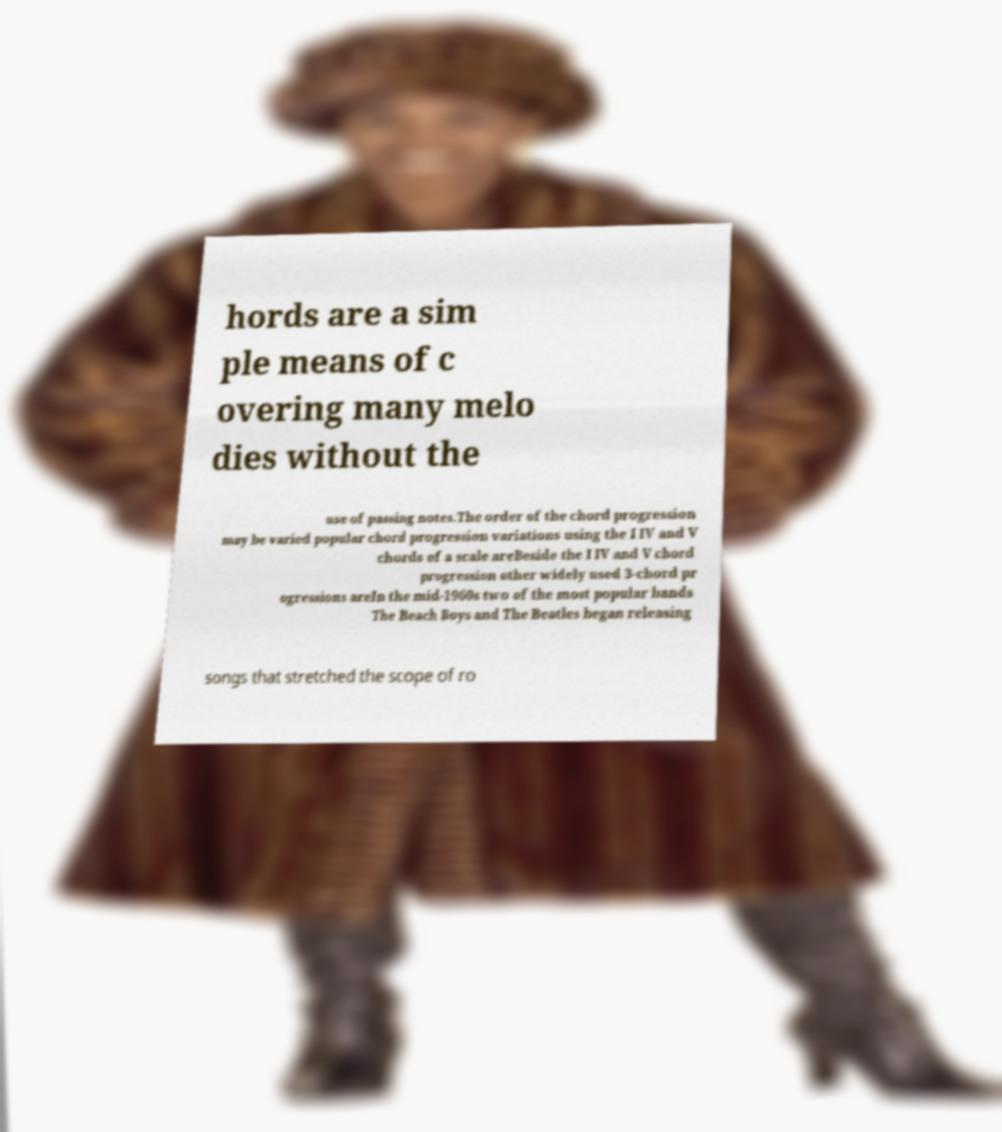Could you assist in decoding the text presented in this image and type it out clearly? hords are a sim ple means of c overing many melo dies without the use of passing notes.The order of the chord progression may be varied popular chord progression variations using the I IV and V chords of a scale areBeside the I IV and V chord progression other widely used 3-chord pr ogressions areIn the mid-1960s two of the most popular bands The Beach Boys and The Beatles began releasing songs that stretched the scope of ro 